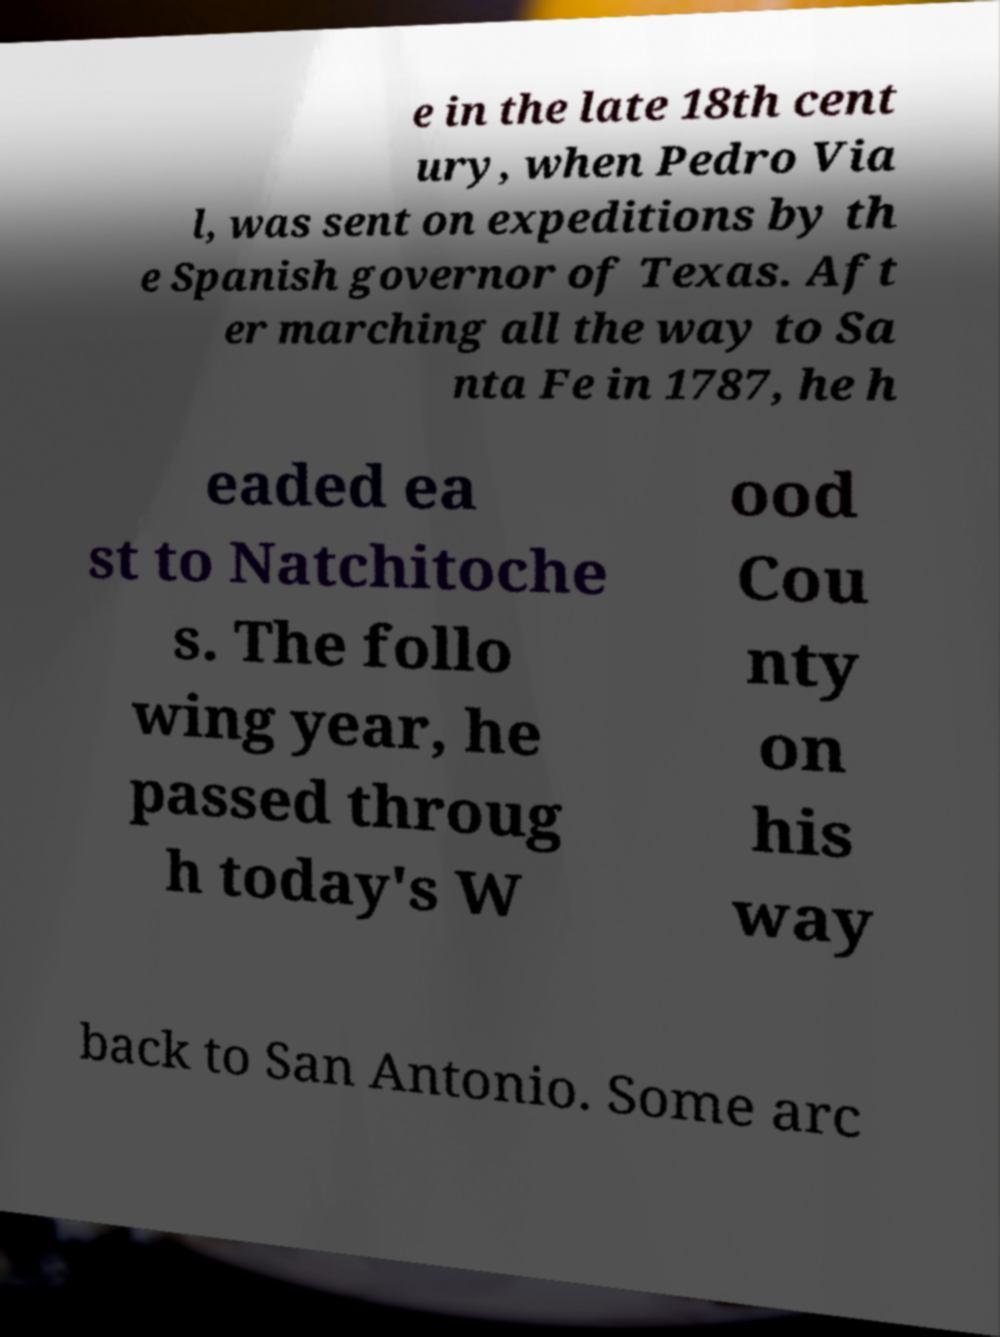I need the written content from this picture converted into text. Can you do that? e in the late 18th cent ury, when Pedro Via l, was sent on expeditions by th e Spanish governor of Texas. Aft er marching all the way to Sa nta Fe in 1787, he h eaded ea st to Natchitoche s. The follo wing year, he passed throug h today's W ood Cou nty on his way back to San Antonio. Some arc 